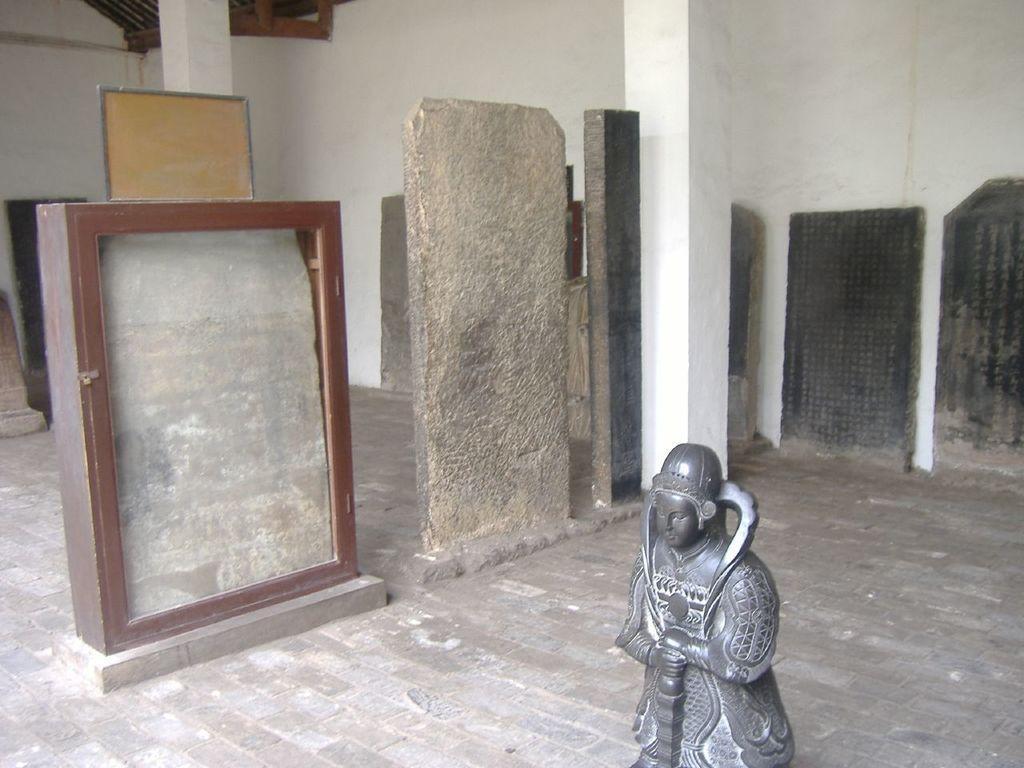Describe this image in one or two sentences. In the picture I can see the statue on the right side. I can see the wooden glass display cabinet on the left side. I can see the vertical rock structures. There is a pillar on the right side. 